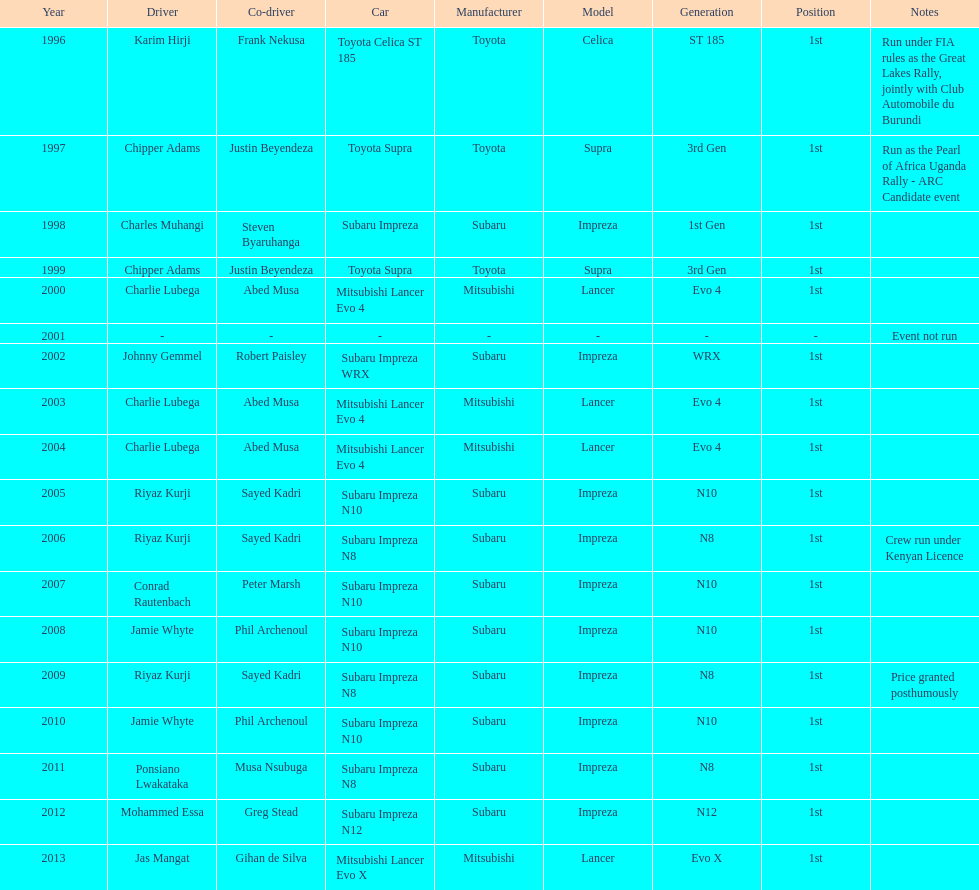Which was the only year that the event was not run? 2001. 